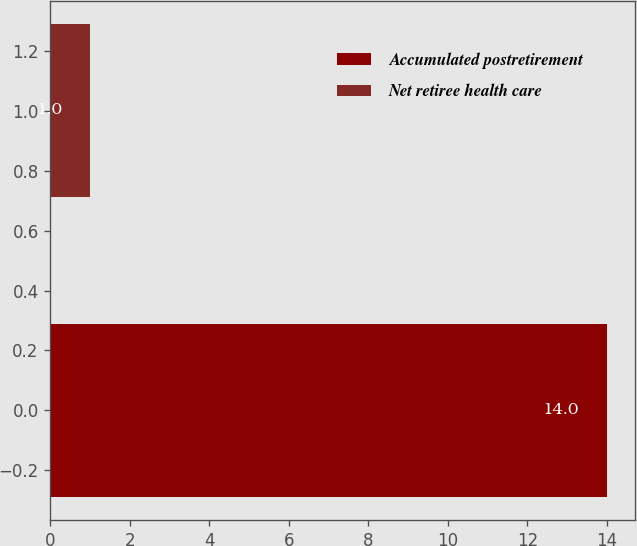Convert chart to OTSL. <chart><loc_0><loc_0><loc_500><loc_500><bar_chart><fcel>Accumulated postretirement<fcel>Net retiree health care<nl><fcel>14<fcel>1<nl></chart> 